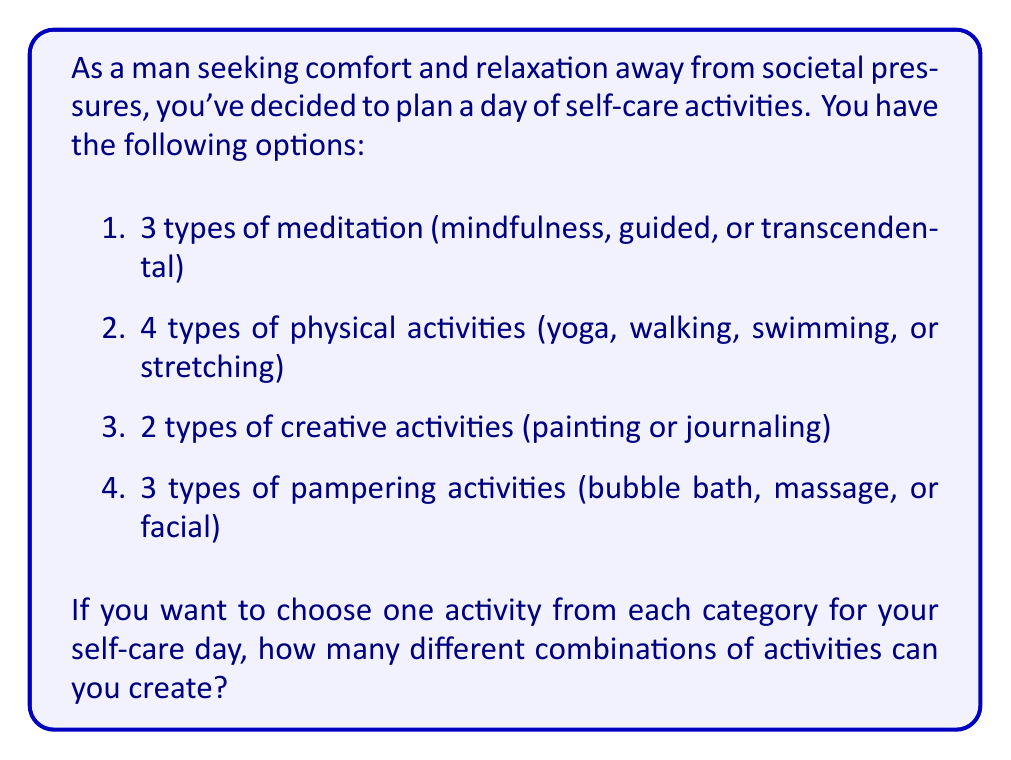Can you answer this question? To solve this problem, we'll use the multiplication principle of counting. This principle states that if we have a sequence of independent choices, the total number of ways to make these choices is the product of the number of ways to make each individual choice.

Let's break it down step by step:

1. For meditation, you have 3 choices.
2. For physical activities, you have 4 choices.
3. For creative activities, you have 2 choices.
4. For pampering activities, you have 3 choices.

Since you're choosing one activity from each category, and the choices are independent of each other, we multiply these numbers together:

$$ \text{Total combinations} = 3 \times 4 \times 2 \times 3 $$

Now, let's calculate:

$$ \begin{align*}
\text{Total combinations} &= 3 \times 4 \times 2 \times 3 \\
&= 12 \times 2 \times 3 \\
&= 24 \times 3 \\
&= 72
\end{align*} $$

This means you can create 72 different combinations of self-care activities for your relaxing day.
Answer: 72 combinations 